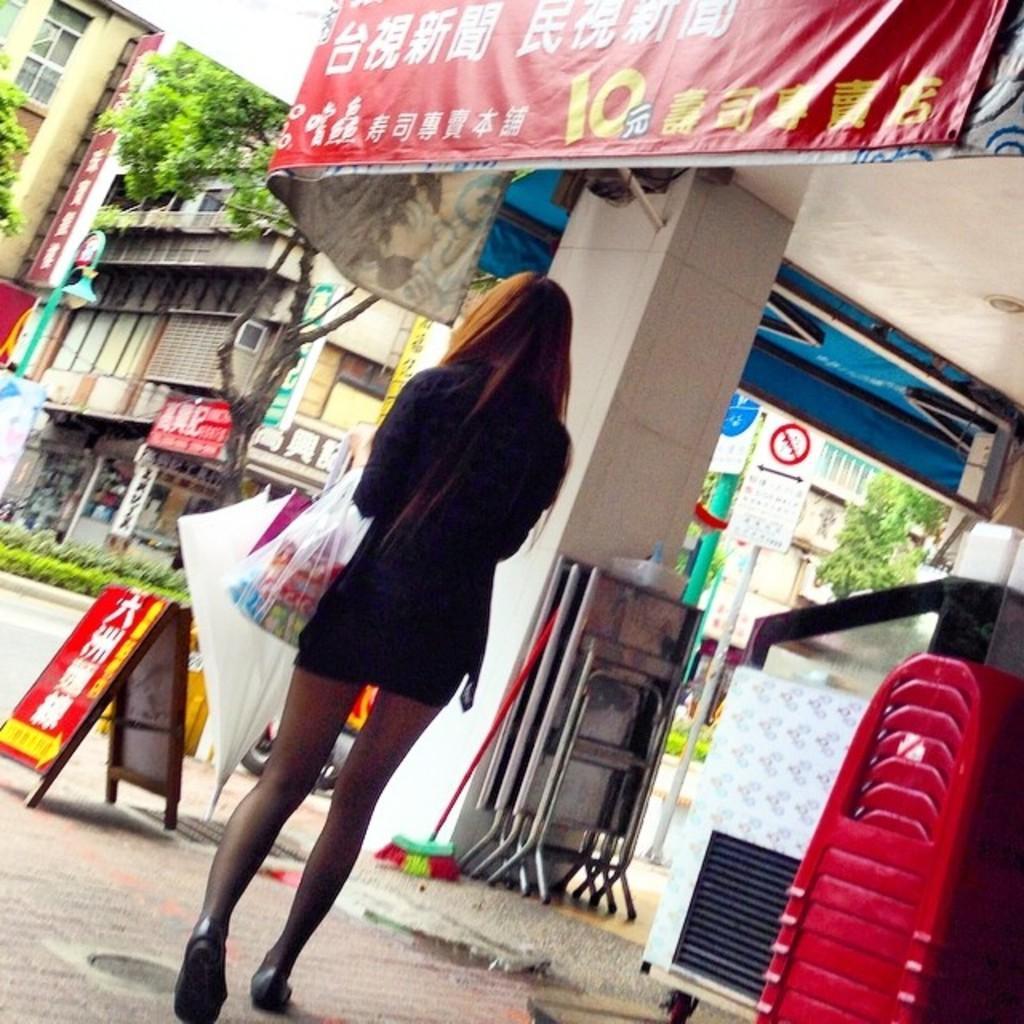How would you summarize this image in a sentence or two? In this picture we can see a woman on the ground, she is holding an umbrella and carrying a polythene cover, here we can see buildings, trees, stools, plants, banners, posters, sign board, poles and some objects. 